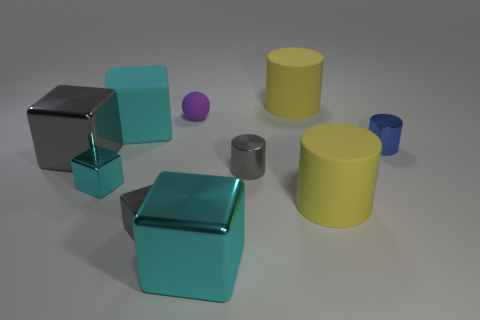How many small spheres have the same color as the rubber cube?
Keep it short and to the point. 0. How many objects are rubber things that are behind the big cyan matte thing or large rubber things?
Your answer should be very brief. 4. There is another cylinder that is the same material as the small blue cylinder; what color is it?
Your answer should be very brief. Gray. Are there any cyan cylinders that have the same size as the purple thing?
Give a very brief answer. No. What number of objects are either big gray cubes behind the tiny cyan object or objects behind the tiny gray metal cylinder?
Offer a terse response. 5. The blue object that is the same size as the purple ball is what shape?
Your answer should be compact. Cylinder. Is there a small cyan shiny object of the same shape as the tiny purple thing?
Provide a succinct answer. No. Is the number of yellow matte spheres less than the number of cyan rubber blocks?
Your answer should be compact. Yes. Do the cyan metallic block that is behind the large cyan metallic block and the yellow thing that is in front of the cyan matte thing have the same size?
Provide a short and direct response. No. What number of objects are either large cyan things or gray metallic objects?
Provide a succinct answer. 5. 